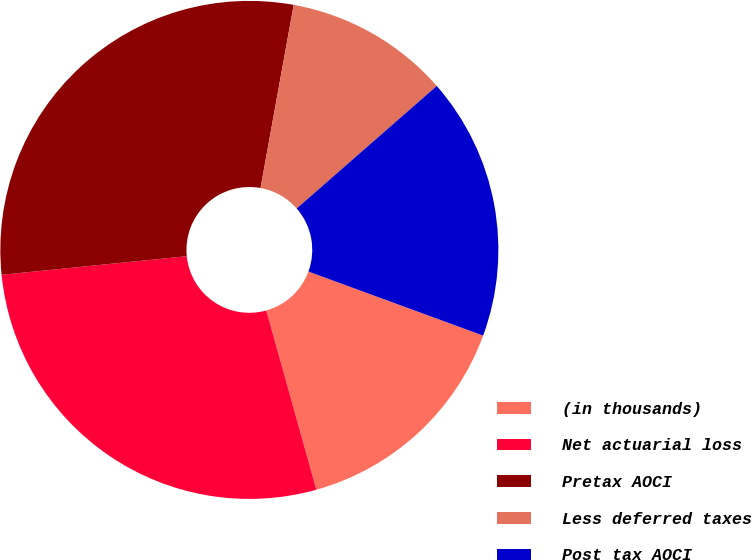<chart> <loc_0><loc_0><loc_500><loc_500><pie_chart><fcel>(in thousands)<fcel>Net actuarial loss<fcel>Pretax AOCI<fcel>Less deferred taxes<fcel>Post tax AOCI<nl><fcel>15.07%<fcel>27.74%<fcel>29.44%<fcel>10.71%<fcel>17.03%<nl></chart> 